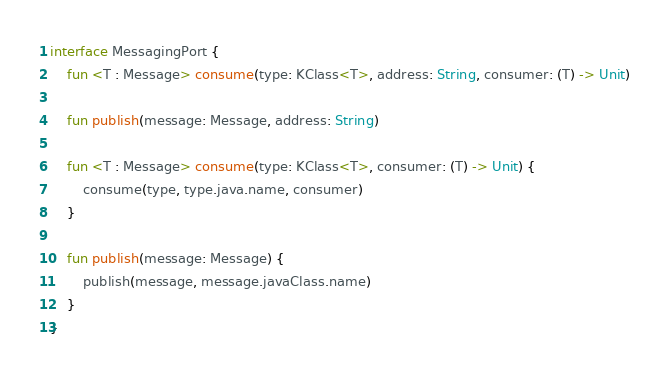Convert code to text. <code><loc_0><loc_0><loc_500><loc_500><_Kotlin_>interface MessagingPort {
    fun <T : Message> consume(type: KClass<T>, address: String, consumer: (T) -> Unit)

    fun publish(message: Message, address: String)

    fun <T : Message> consume(type: KClass<T>, consumer: (T) -> Unit) {
        consume(type, type.java.name, consumer)
    }

    fun publish(message: Message) {
        publish(message, message.javaClass.name)
    }
}
</code> 